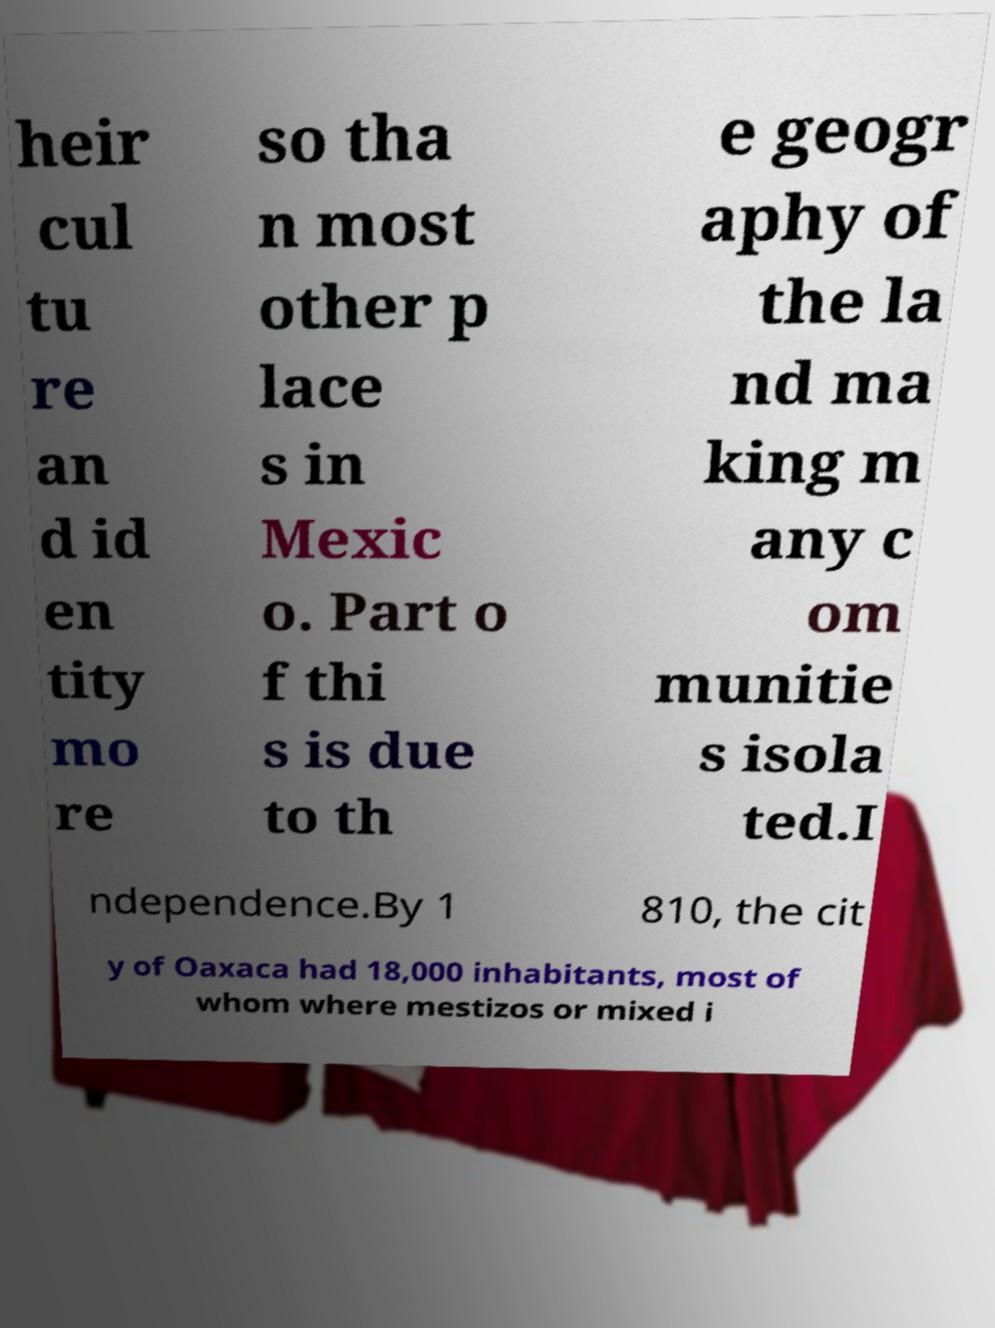Could you extract and type out the text from this image? heir cul tu re an d id en tity mo re so tha n most other p lace s in Mexic o. Part o f thi s is due to th e geogr aphy of the la nd ma king m any c om munitie s isola ted.I ndependence.By 1 810, the cit y of Oaxaca had 18,000 inhabitants, most of whom where mestizos or mixed i 